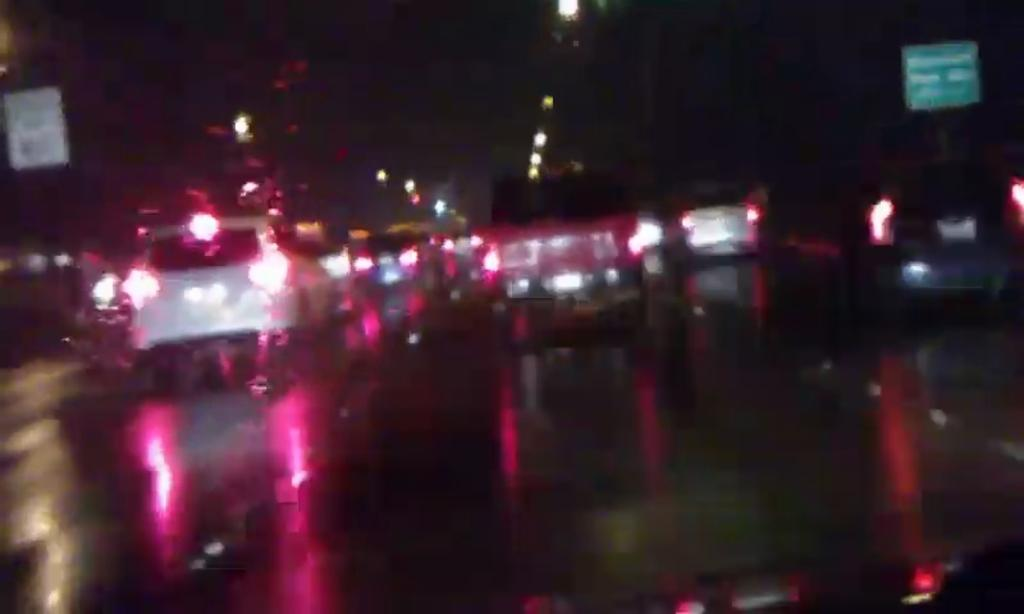What is the main feature of the image? There is a road in the image. What is happening on the road? There are vehicles on the road. What else can be seen in the image besides the road and vehicles? There are boards and lights visible in the image. What type of lamp is being used for dinner in the image? There is no lamp or dinner present in the image; it features a road with vehicles, boards, and lights. 